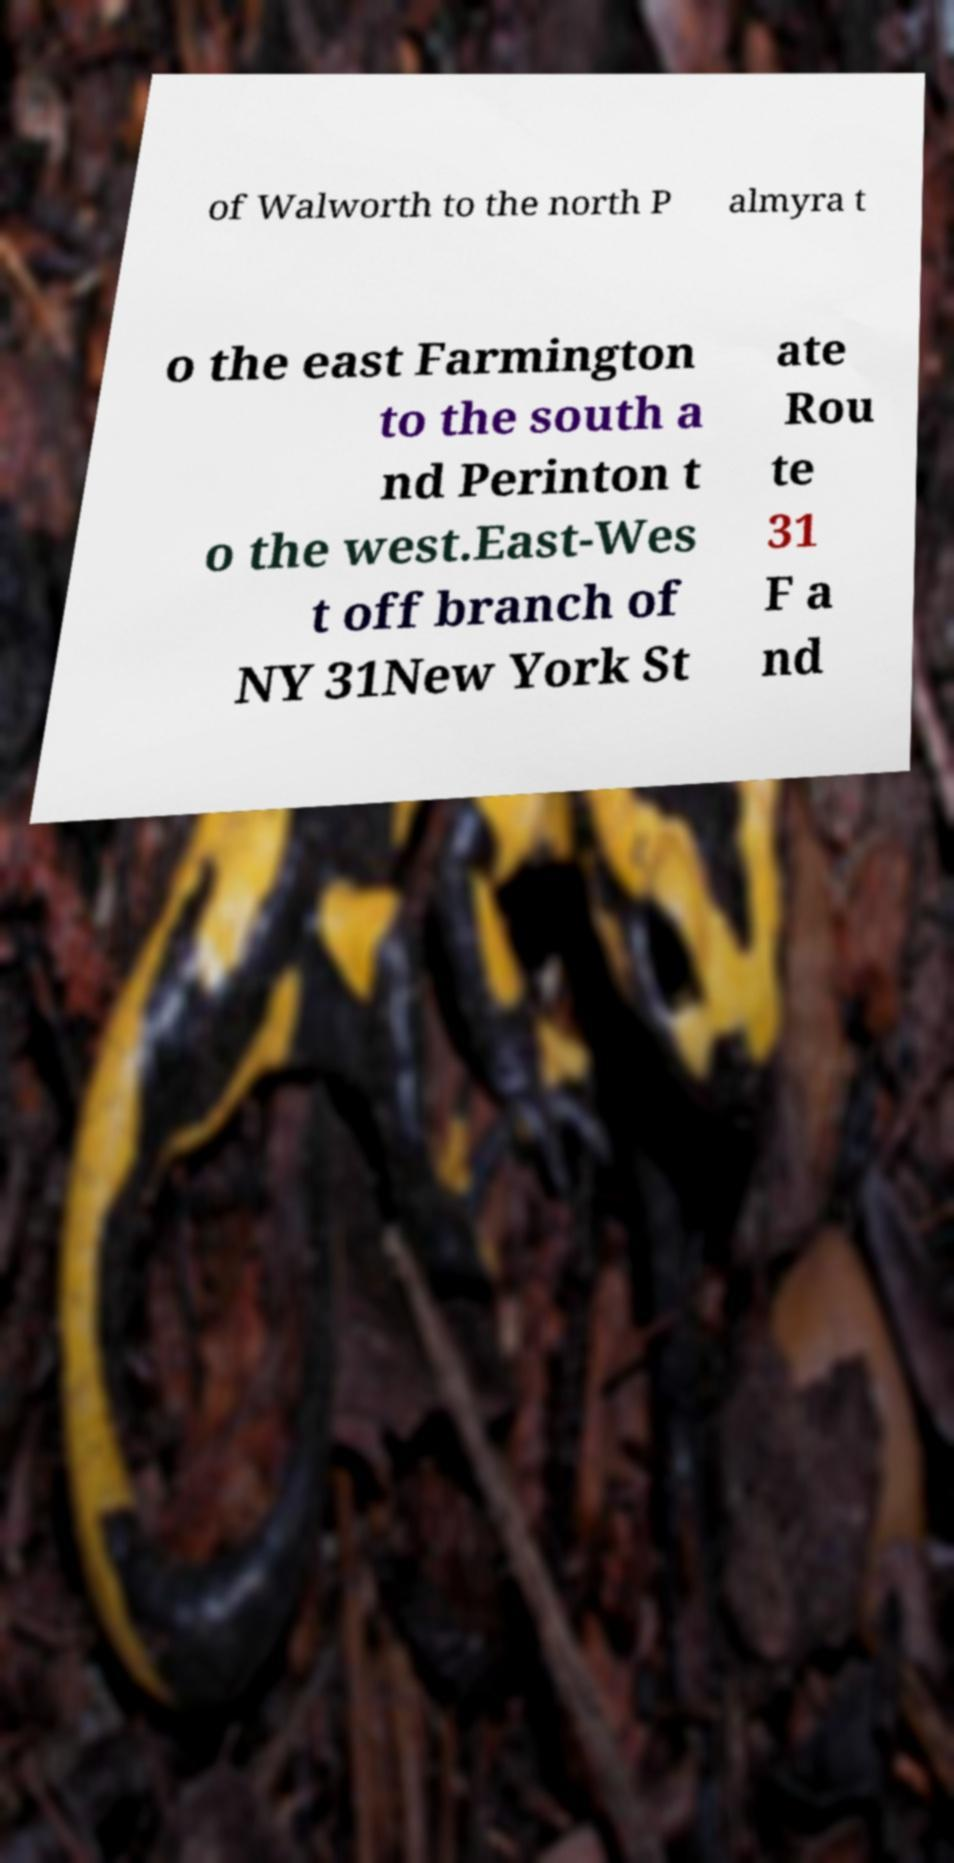Please read and relay the text visible in this image. What does it say? of Walworth to the north P almyra t o the east Farmington to the south a nd Perinton t o the west.East-Wes t off branch of NY 31New York St ate Rou te 31 F a nd 